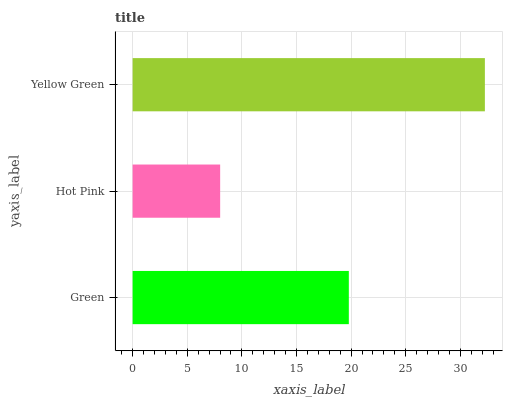Is Hot Pink the minimum?
Answer yes or no. Yes. Is Yellow Green the maximum?
Answer yes or no. Yes. Is Yellow Green the minimum?
Answer yes or no. No. Is Hot Pink the maximum?
Answer yes or no. No. Is Yellow Green greater than Hot Pink?
Answer yes or no. Yes. Is Hot Pink less than Yellow Green?
Answer yes or no. Yes. Is Hot Pink greater than Yellow Green?
Answer yes or no. No. Is Yellow Green less than Hot Pink?
Answer yes or no. No. Is Green the high median?
Answer yes or no. Yes. Is Green the low median?
Answer yes or no. Yes. Is Yellow Green the high median?
Answer yes or no. No. Is Hot Pink the low median?
Answer yes or no. No. 